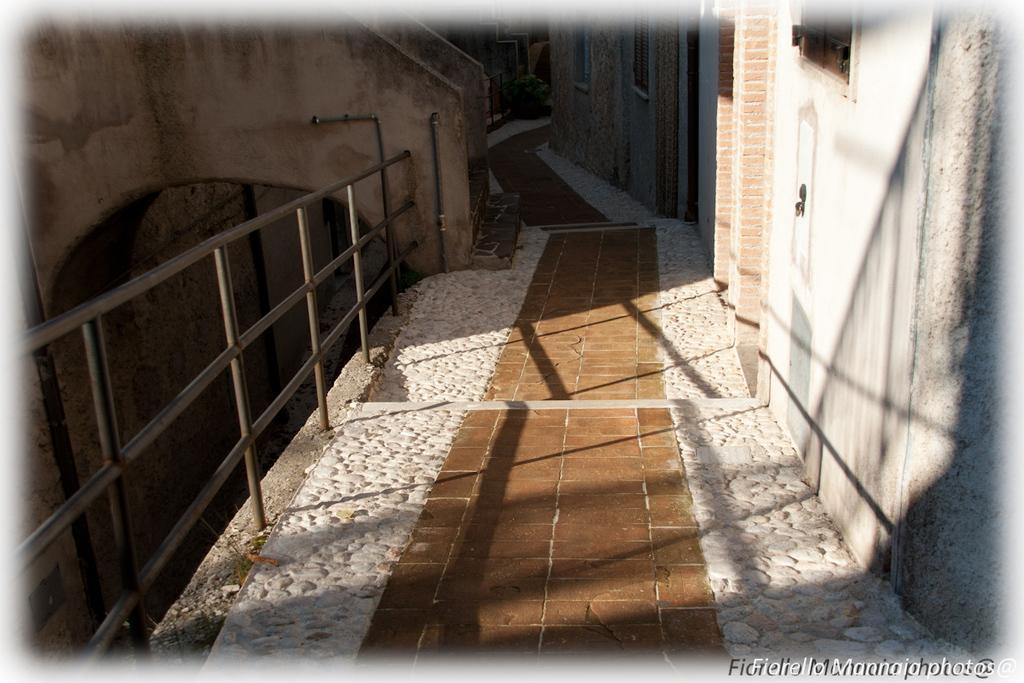How would you summarize this image in a sentence or two? In this image there is a floor, on the left side there is fencing, on the right side there is a wall, to that wall there are door, in the bottom right there is text. 